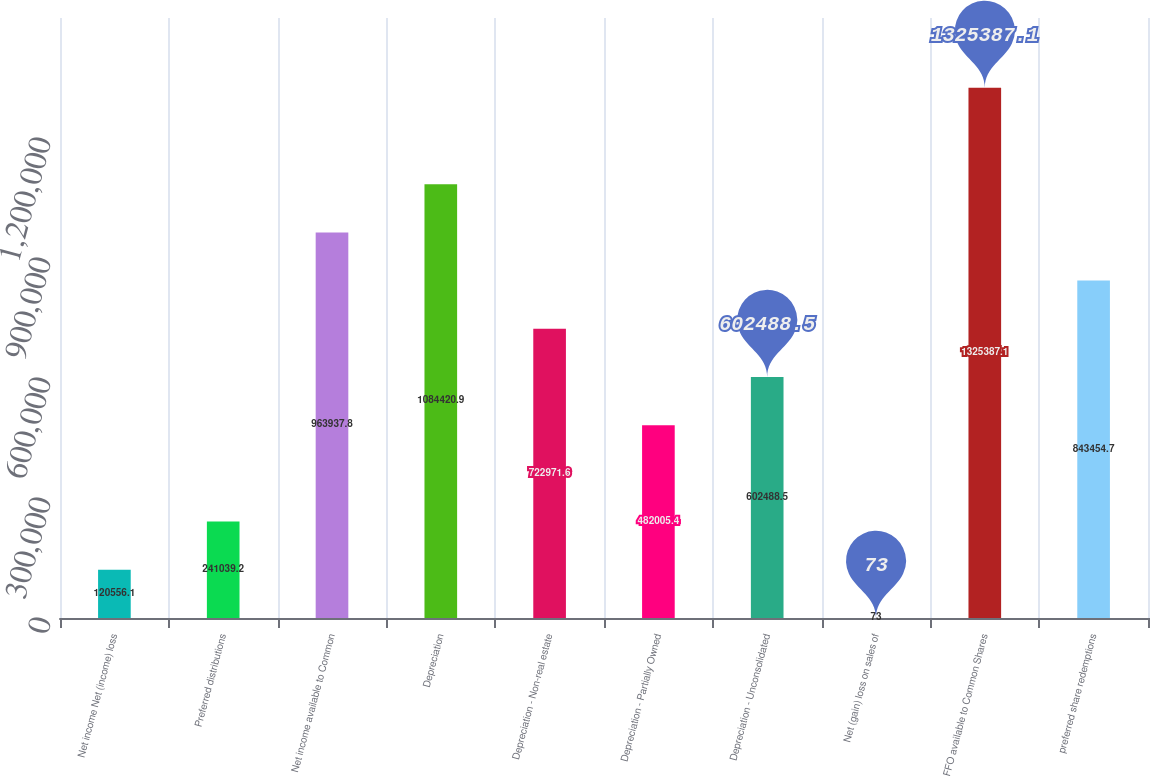Convert chart to OTSL. <chart><loc_0><loc_0><loc_500><loc_500><bar_chart><fcel>Net income Net (income) loss<fcel>Preferred distributions<fcel>Net income available to Common<fcel>Depreciation<fcel>Depreciation - Non-real estate<fcel>Depreciation - Partially Owned<fcel>Depreciation - Unconsolidated<fcel>Net (gain) loss on sales of<fcel>FFO available to Common Shares<fcel>preferred share redemptions<nl><fcel>120556<fcel>241039<fcel>963938<fcel>1.08442e+06<fcel>722972<fcel>482005<fcel>602488<fcel>73<fcel>1.32539e+06<fcel>843455<nl></chart> 